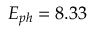<formula> <loc_0><loc_0><loc_500><loc_500>E _ { p h } = 8 . 3 3</formula> 